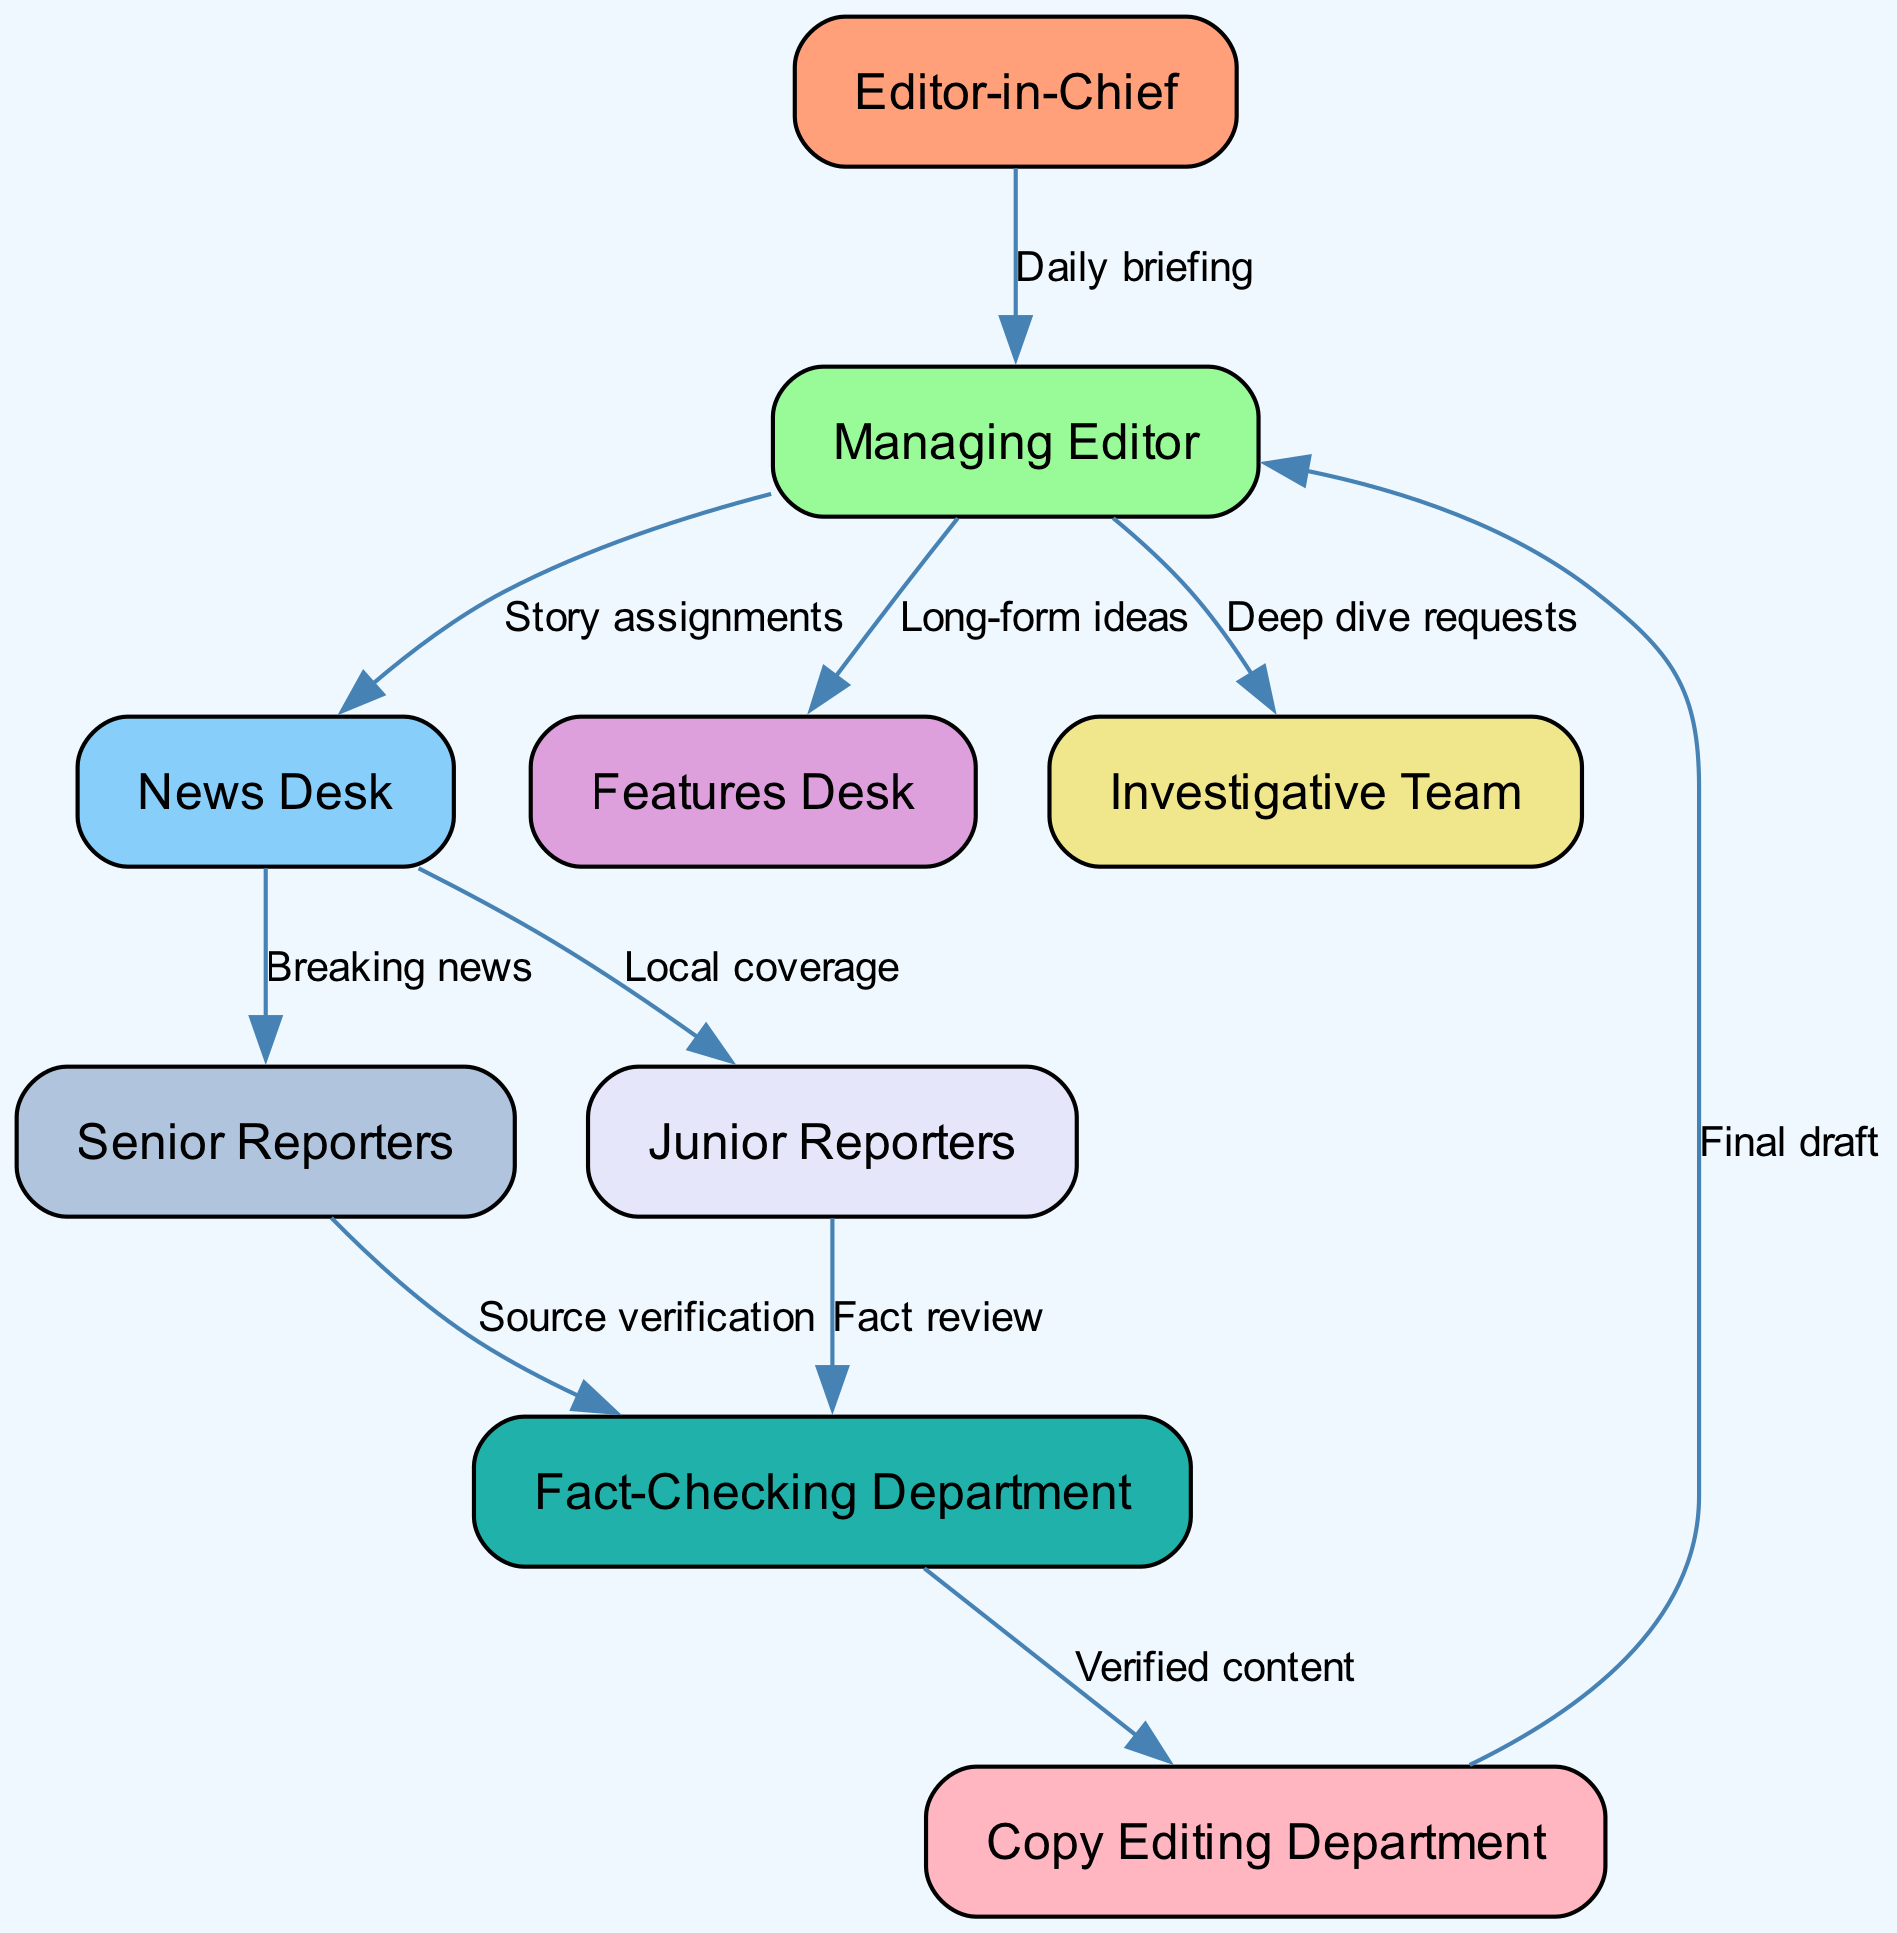What is the total number of nodes in the diagram? The diagram contains nine nodes, as listed: Editor-in-Chief, Managing Editor, News Desk, Features Desk, Investigative Team, Fact-Checking Department, Copy Editing Department, Senior Reporters, and Junior Reporters.
Answer: 9 Who receives story assignments from the Managing Editor? The edges in the diagram indicate that the Managing Editor assigns stories directly to the News Desk.
Answer: News Desk What type of requests are sent from the Managing Editor to the Investigative Team? The label on the edge connecting these nodes indicates that the Managing Editor sends "Deep dive requests" to the Investigative Team.
Answer: Deep dive requests Which department verifies sources for senior reporters? The flow from Senior Reporters to the Fact-Checking Department shows that source verification is the responsibility of the Fact-Checking Department in this context.
Answer: Fact-Checking Department How many types of reporters are indicated in the diagram? The diagram distinguishes between two types of reporters: Senior Reporters and Junior Reporters.
Answer: 2 What does the Copy Editing Department receive from the Fact-Checking Department? The connection from Fact-Checking to Copy Editing indicates that the Copy Editing Department receives "Verified content".
Answer: Verified content From whom does the Managing Editor receive the final draft? The diagram shows an edge from Copy Editing to Managing Editor labeled "Final draft," indicating that the Managing Editor receives the final draft from the Copy Editing Department.
Answer: Copy Editing Department What is the main purpose of the edge from News Desk to Senior Reporters? The relationship is described by the label "Breaking news" on the edge, indicating that this is the purpose of the edge.
Answer: Breaking news How does the communication flow from Junior Reporters to the Fact-Checking Department? The edge indicates that Junior Reporters send their work labeled "Fact review" to the Fact-Checking Department, illustrating a clear flow of communication.
Answer: Fact review 